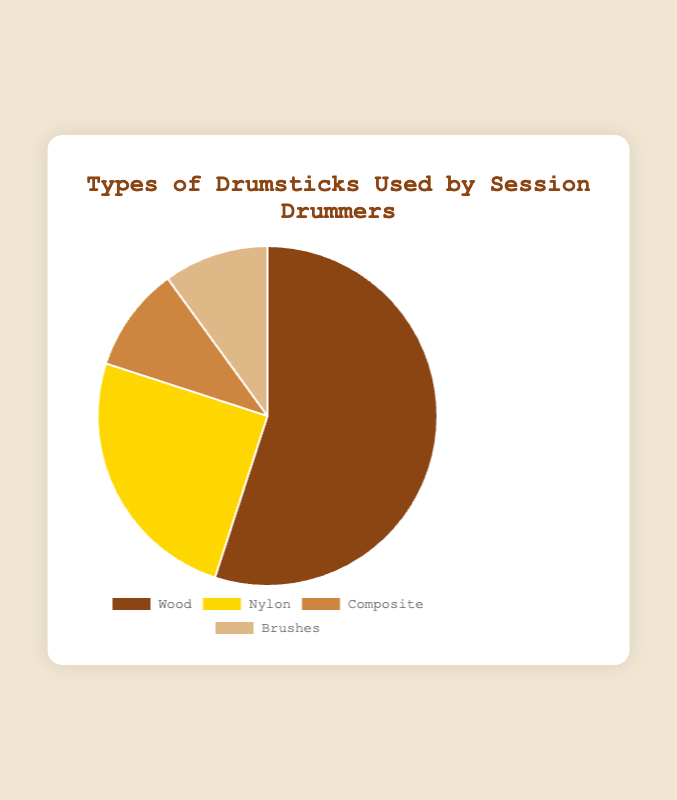What is the most common type of drumstick used? The chart shows different types of drumsticks and their usage percentages. Wood drumsticks have the highest percentage at 55%.
Answer: Wood What is the difference in usage between Nylon and Composite drumsticks? The usage of Nylon drumsticks is 25%, and Composite drumsticks are 10%. The difference is 25% - 10% = 15%.
Answer: 15% Which two types of drumsticks are used equally? According to the chart, Composite and Brushes drumsticks each have a usage percentage of 10%.
Answer: Composite and Brushes How much more popular are Wood drumsticks compared to the least used type of drumstick? Wood drumsticks are used 55%, and both Composite and Brushes are used 10%. The difference is 55% - 10% = 45%.
Answer: 45% List the drumsticks in order of their usage popularity. By examining the percentages, we can list them in descending order: Wood (55%), Nylon (25%), Composite (10%), Brushes (10%).
Answer: Wood, Nylon, Composite, Brushes What is the combined usage percentage of Wood and Nylon drumsticks? Adding the percentages for Wood (55%) and Nylon (25%) gives 55% + 25% = 80%.
Answer: 80% What is the percentage difference between the most commonly used drumstick and the least commonly used drumstick? The most common is Wood at 55%, and the least common are Composite and Brushes, both at 10%. The difference is 55% - 10% = 45%.
Answer: 45% What percentage of drummers use either Composite or Brushes drumsticks? Combining the usage of Composite (10%) and Brushes (10%) results in 10% + 10% = 20%.
Answer: 20% If you combine the usage percentages of Composite and Brushes, does it exceed or fall short of Nylon drumsticks usage? Composite and Brushes combined are 10% + 10% = 20%. Nylon is used 25%, thus 20% is less than 25%.
Answer: falls short 